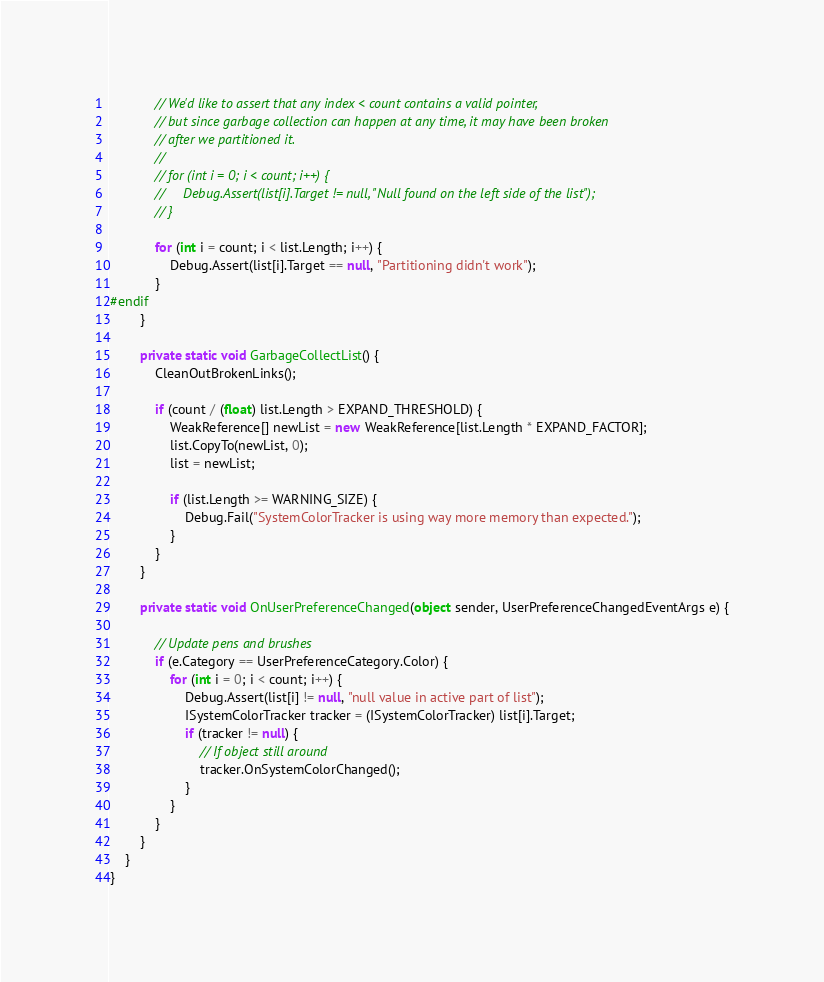<code> <loc_0><loc_0><loc_500><loc_500><_C#_>            // We'd like to assert that any index < count contains a valid pointer,
            // but since garbage collection can happen at any time, it may have been broken
            // after we partitioned it.
            //
            // for (int i = 0; i < count; i++) {
            //     Debug.Assert(list[i].Target != null, "Null found on the left side of the list");
            // }

            for (int i = count; i < list.Length; i++) {
                Debug.Assert(list[i].Target == null, "Partitioning didn't work");
            }
#endif
        }
        
        private static void GarbageCollectList() {
            CleanOutBrokenLinks();

            if (count / (float) list.Length > EXPAND_THRESHOLD) {
                WeakReference[] newList = new WeakReference[list.Length * EXPAND_FACTOR];
                list.CopyTo(newList, 0);
                list = newList;

                if (list.Length >= WARNING_SIZE) {
                    Debug.Fail("SystemColorTracker is using way more memory than expected.");
                }
            }
        }            

        private static void OnUserPreferenceChanged(object sender, UserPreferenceChangedEventArgs e) {

            // Update pens and brushes
            if (e.Category == UserPreferenceCategory.Color) {
                for (int i = 0; i < count; i++) {
                    Debug.Assert(list[i] != null, "null value in active part of list");
                    ISystemColorTracker tracker = (ISystemColorTracker) list[i].Target;
                    if (tracker != null) {
                        // If object still around
                        tracker.OnSystemColorChanged();
                    }
                }
            }
        }
    }
}


</code> 